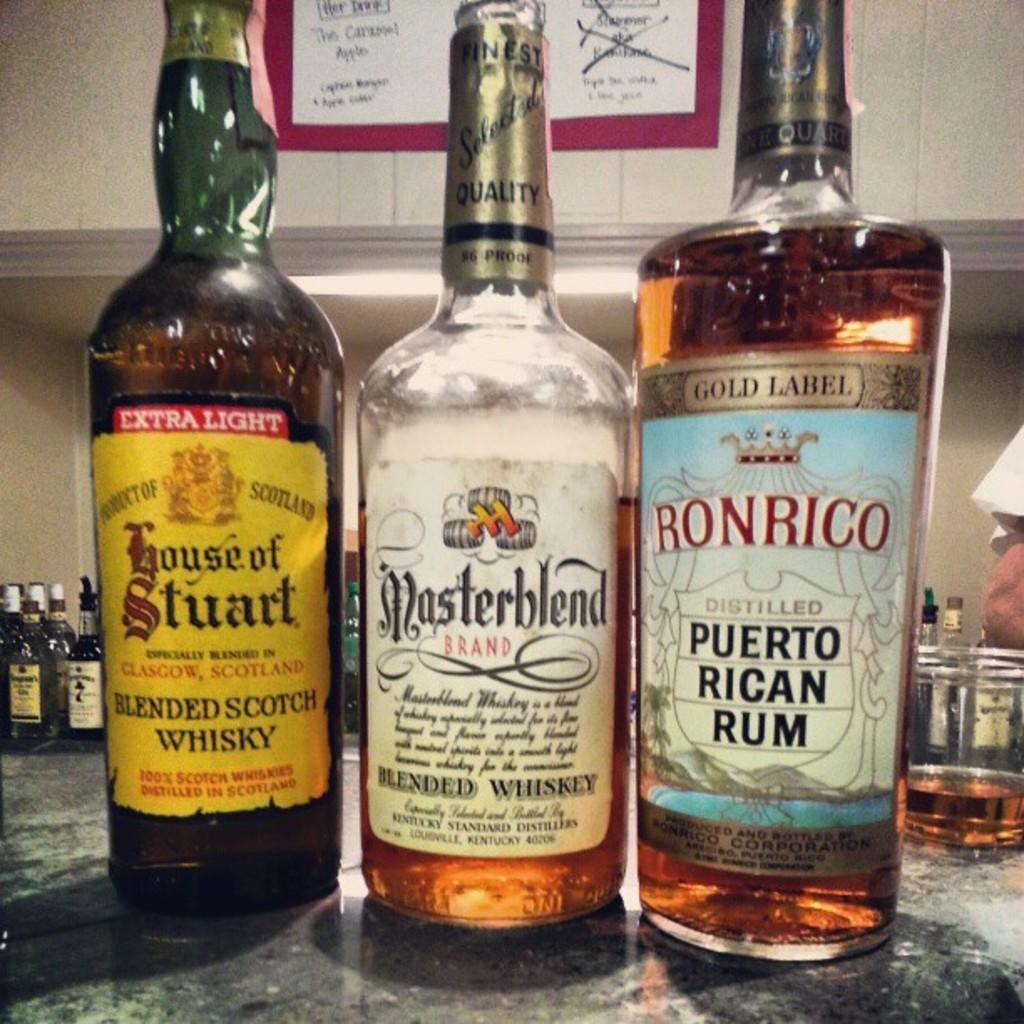<image>
Render a clear and concise summary of the photo. Bottles of whisky include House of Stuart, Masterblend and Ronrico on their labels. 